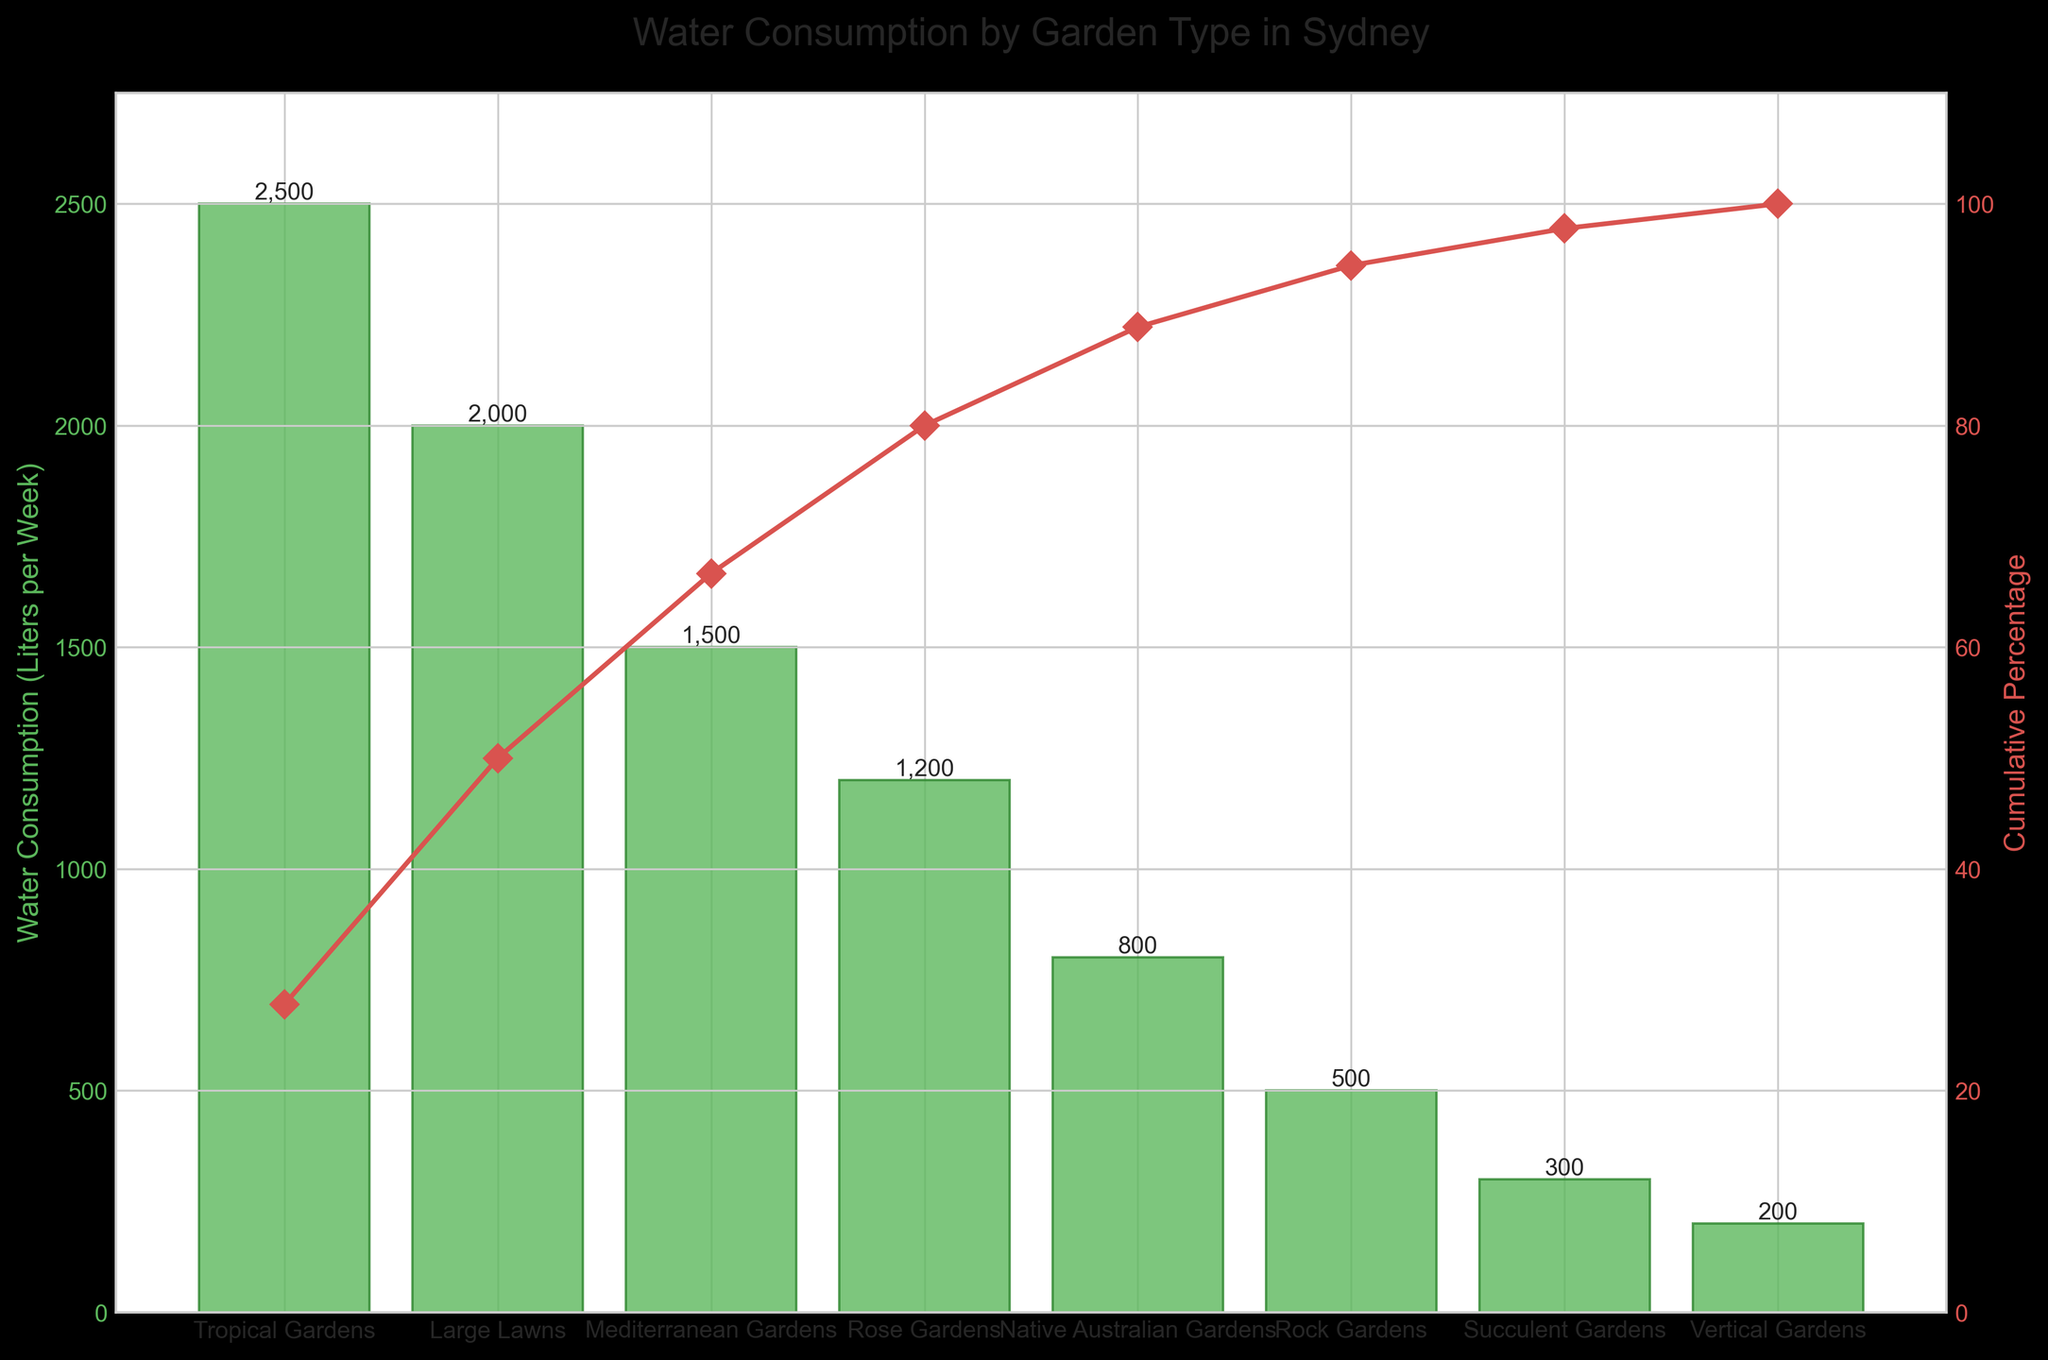What's the title of the chart? The title of the chart is typically displayed at the top of the figure. In this chart, the title clearly indicates the subject matter.
Answer: Water Consumption by Garden Type in Sydney What is the garden type with the highest water consumption? By looking at the bars, the highest one represents the garden type with the highest water usage.
Answer: Tropical Gardens How much water does a Tropical Garden consume per week? The height of the bar corresponding to Tropical Gardens represents its water consumption. The value is labeled above the bar.
Answer: 2500 liters per week Which garden type has the lowest water consumption? The shortest bar on the chart indicates the garden type with the least water usage, found at the end of the sorted list.
Answer: Vertical Gardens What's the cumulative percentage of water consumed by the top three garden types? The cumulative percentage line intersects the percentage values for each garden type. For the top three garden types, find their corresponding cumulative percentage.
Answer: 73.68% How much more water does a Rose Garden consume compared to a Succulent Garden? Subtract the water consumption value of the Succulent Garden from the Rose Garden.
Answer: 900 liters per week (1200 - 300) Which garden types account for approximately 80% of total water consumption? Check the cumulative percentage line and identify which garden types collectively reach around 80%.
Answer: Tropical Gardens, Large Lawns, Mediterranean Gardens, and Rose Gardens What is the average water consumption of Large Lawns and Native Australian Gardens? Add the water consumption values of Large Lawns and Native Australian Gardens, then divide by 2.
Answer: 1400 liters per week ((2000 + 800) / 2) How does the water consumption of Mediterranean Gardens compare to Rock Gardens? Compare the height of the bars for Mediterranean Gardens and Rock Gardens.
Answer: Mediterranean Gardens consume more water than Rock Gardens What percentage of total water consumption is represented by Tropical Gardens alone? Divide the water consumption of Tropical Gardens by the total water consumption and multiply by 100.
Answer: 27.78% 